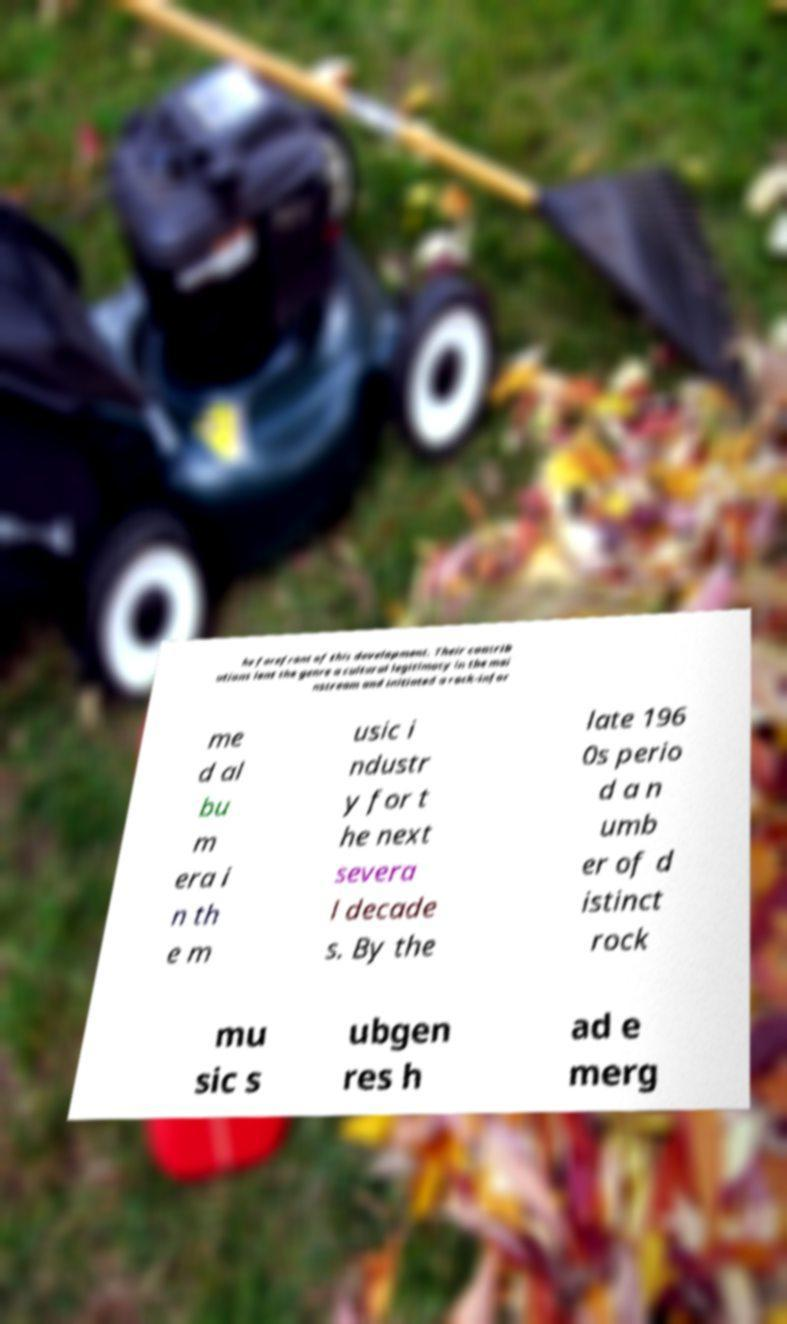Please identify and transcribe the text found in this image. he forefront of this development. Their contrib utions lent the genre a cultural legitimacy in the mai nstream and initiated a rock-infor me d al bu m era i n th e m usic i ndustr y for t he next severa l decade s. By the late 196 0s perio d a n umb er of d istinct rock mu sic s ubgen res h ad e merg 